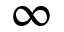<formula> <loc_0><loc_0><loc_500><loc_500>\infty</formula> 